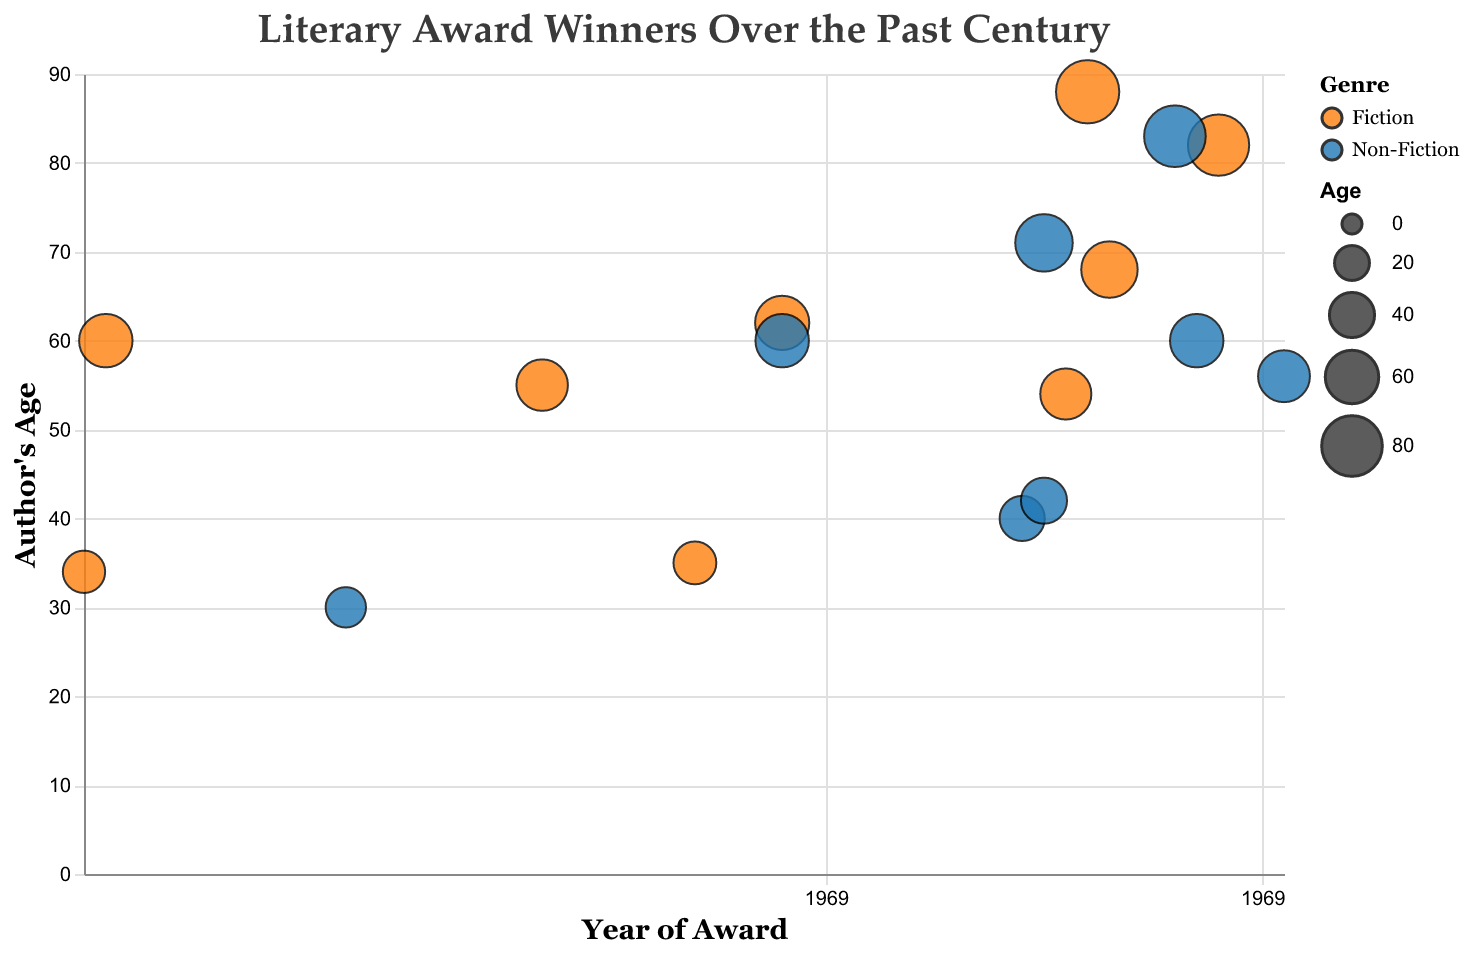In what year did Harper Lee win a Pulitzer Prize? Locate Harper Lee's data point, and observe the "Year" tooltip which is 1961.
Answer: 1961 Who was the oldest author to win an award in the dataset? Identify the data point with the highest "Age" value, and find Doris Lessing, who won at age 88.
Answer: Doris Lessing Among the authors who won Nobel Prizes, who was the youngest? Filter the data points by "Award" to Nobel Prize and compare their ages, identifying Gabriel Garcia Marquez at age 55.
Answer: Gabriel Garcia Marquez How many Non-Fiction award winners are represented in the figure? Count the data points where the "Genre" is Non-Fiction. There are seven such points.
Answer: 7 What is the average age of Non-Fiction award winners in the dataset? Sum the ages of Non-Fiction winners (83 + 40 + 30 + 60 + 71 + 56 + 60 = 400) and divide by the number of data points (7). The average age is 400/7 ≈ 57.14.
Answer: 57.14 How does the proportion of Fiction to Non-Fiction award winners in the dataset compare? Count the data points for Fiction (10) and Non-Fiction (7), then compare the numbers. Fiction: 10, Non-Fiction: 7.
Answer: Fiction: 10, Non-Fiction: 7 Which author won a major award most recently in the dataset? Identify the data point with the latest year, which is Philippe Sands in 2016.
Answer: Philippe Sands How does the age range of Fiction winners compare to Non-Fiction winners? Identify the minimum and maximum ages for Fiction (34-88) and Non-Fiction winners (30-83), then compare these ranges. Fiction range: 34-88, Non-Fiction range: 30-83.
Answer: Fiction: 34-88, Non-Fiction: 30-83 What is the general trend of the authors' ages over the years? Observe the distribution of data points along the X (Year) and Y (Age) axes. There is no clear upward or downward trend in age over the years.
Answer: No clear trend 